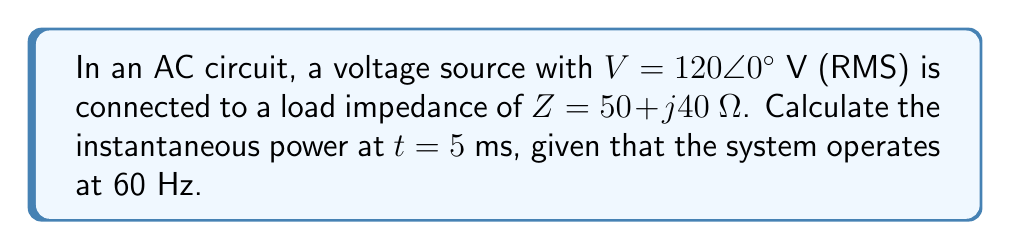What is the answer to this math problem? To solve this problem, we'll follow these steps:

1) First, calculate the complex power $S$:
   $$S = \frac{|V|^2}{Z^*} = \frac{120^2}{50 - j40} = 172.8 + j138.24 \text{ VA}$$

2) The real part of $S$ is the average power $P$, and the imaginary part is the reactive power $Q$:
   $$P = 172.8 \text{ W}, Q = 138.24 \text{ VAR}$$

3) The apparent power $|S|$ is:
   $$|S| = \sqrt{P^2 + Q^2} = \sqrt{172.8^2 + 138.24^2} = 221.11 \text{ VA}$$

4) The power factor angle $\theta$ is:
   $$\theta = \tan^{-1}\left(\frac{Q}{P}\right) = \tan^{-1}\left(\frac{138.24}{172.8}\right) = 38.66^\circ$$

5) The instantaneous power $p(t)$ is given by:
   $$p(t) = |S| \cos(\omega t - \theta)$$
   where $\omega = 2\pi f = 2\pi(60) = 377 \text{ rad/s}$

6) At $t = 5 \text{ ms}$:
   $$p(5\text{ ms}) = 221.11 \cos(377 \cdot 0.005 - 38.66^\circ)$$
   $$= 221.11 \cos(1.885 - 0.675) = 221.11 \cos(1.21)$$
   $$= 221.11 \cdot 0.3627 = 80.20 \text{ W}$$
Answer: $80.20 \text{ W}$ 